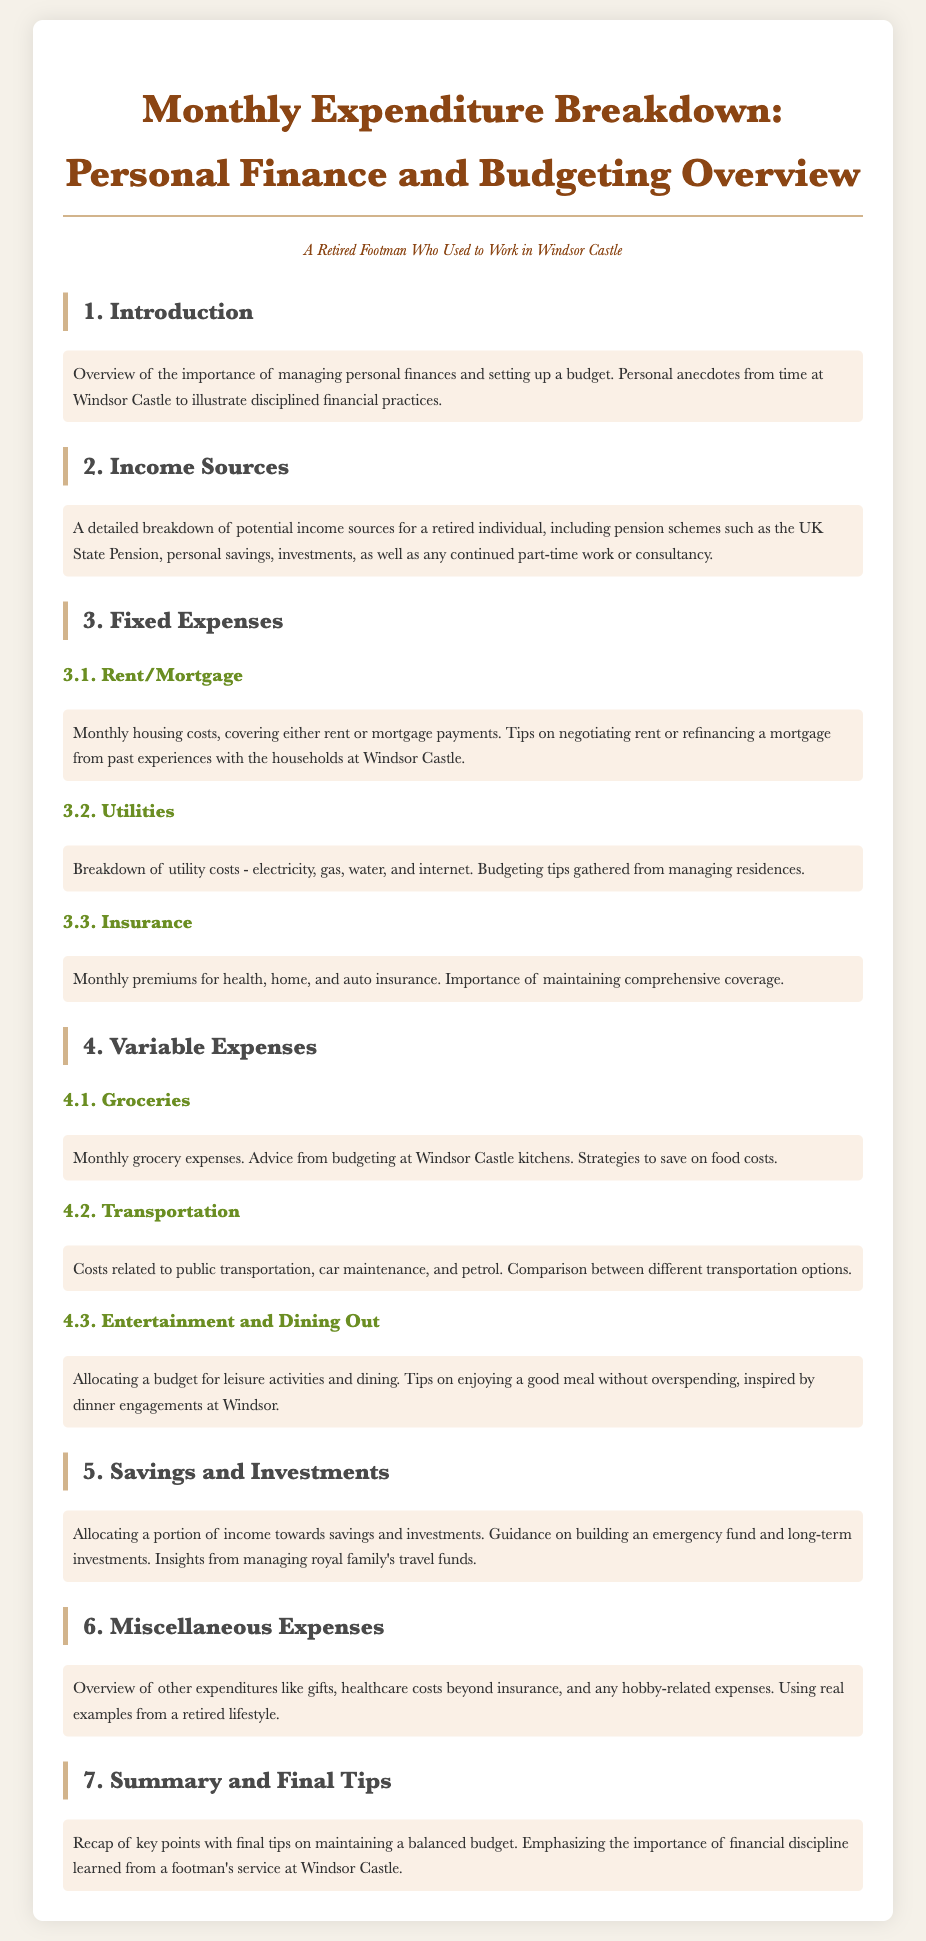What is the main topic of the document? The document focuses on a detailed breakdown of monthly expenses and budgeting for personal finance.
Answer: Monthly Expenditure Breakdown What type of income sources are mentioned? The document lists various income sources for a retired individual, such as pension schemes and personal savings.
Answer: Pension schemes, personal savings What are the three categories of fixed expenses outlined? The document details three specific categories of fixed expenses: housing costs, utility costs, and insurance premiums.
Answer: Rent/Mortgage, Utilities, Insurance Which expense category includes dining out? The document has a section specifically dedicated to leisure activities and dining, which is part of variable expenses.
Answer: Entertainment and Dining Out What savings strategy is suggested? The document advises allocating a portion of income towards savings and investments and building an emergency fund.
Answer: Building an emergency fund What type of content is in the section about miscellaneous expenses? The document discusses other expenditures that do not fall into regular categories, including gifts and healthcare costs.
Answer: Gifts, healthcare costs What is emphasized in the summary? The summary emphasizes the importance of maintaining a balanced budget and financial discipline.
Answer: Financial discipline What insights are drawn from managing royal family’s funds? The document provides insights on how to allocate money effectively for savings and investments.
Answer: Savings and Investments What personal experiences are shared in the introduction? The introduction shares personal anecdotes related to disciplined financial practices while working in a royal household.
Answer: Disciplined financial practices 